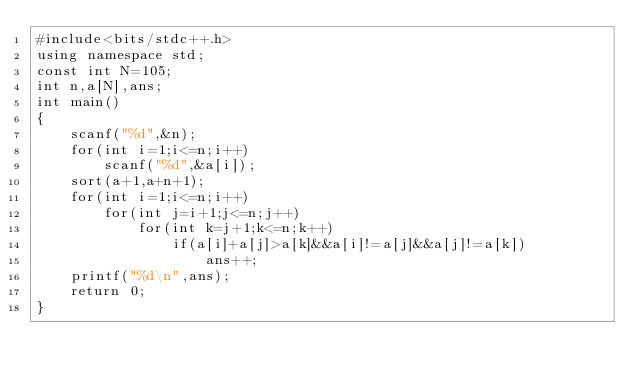Convert code to text. <code><loc_0><loc_0><loc_500><loc_500><_C++_>#include<bits/stdc++.h>
using namespace std;
const int N=105;
int n,a[N],ans;
int main()
{
	scanf("%d",&n);
	for(int i=1;i<=n;i++)
		scanf("%d",&a[i]);
	sort(a+1,a+n+1);
	for(int i=1;i<=n;i++)
		for(int j=i+1;j<=n;j++)
			for(int k=j+1;k<=n;k++)
				if(a[i]+a[j]>a[k]&&a[i]!=a[j]&&a[j]!=a[k])
					ans++;
	printf("%d\n",ans);
	return 0;
}</code> 